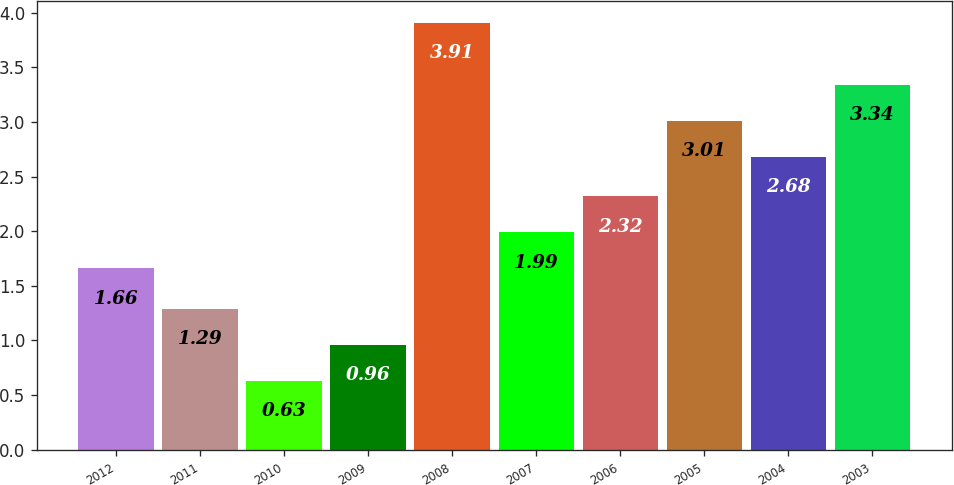Convert chart. <chart><loc_0><loc_0><loc_500><loc_500><bar_chart><fcel>2012<fcel>2011<fcel>2010<fcel>2009<fcel>2008<fcel>2007<fcel>2006<fcel>2005<fcel>2004<fcel>2003<nl><fcel>1.66<fcel>1.29<fcel>0.63<fcel>0.96<fcel>3.91<fcel>1.99<fcel>2.32<fcel>3.01<fcel>2.68<fcel>3.34<nl></chart> 